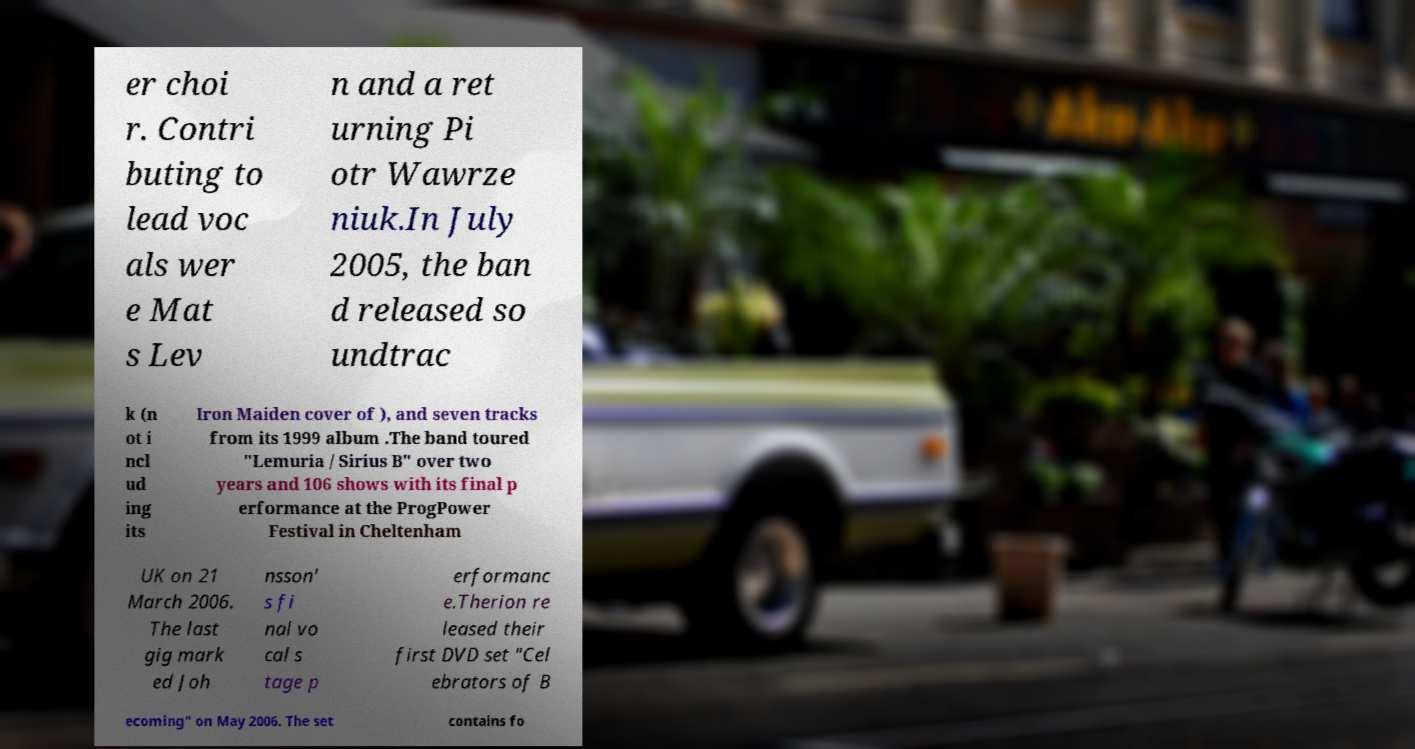For documentation purposes, I need the text within this image transcribed. Could you provide that? er choi r. Contri buting to lead voc als wer e Mat s Lev n and a ret urning Pi otr Wawrze niuk.In July 2005, the ban d released so undtrac k (n ot i ncl ud ing its Iron Maiden cover of ), and seven tracks from its 1999 album .The band toured "Lemuria / Sirius B" over two years and 106 shows with its final p erformance at the ProgPower Festival in Cheltenham UK on 21 March 2006. The last gig mark ed Joh nsson' s fi nal vo cal s tage p erformanc e.Therion re leased their first DVD set "Cel ebrators of B ecoming" on May 2006. The set contains fo 